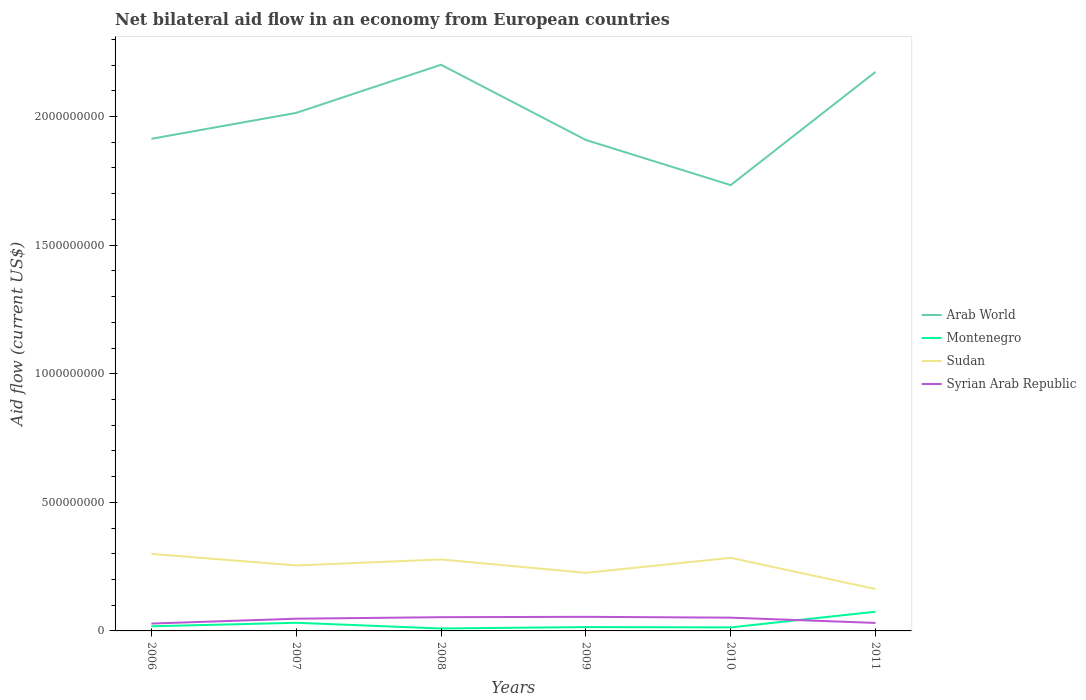Is the number of lines equal to the number of legend labels?
Provide a succinct answer. Yes. Across all years, what is the maximum net bilateral aid flow in Montenegro?
Ensure brevity in your answer.  9.50e+06. In which year was the net bilateral aid flow in Arab World maximum?
Offer a terse response. 2010. What is the total net bilateral aid flow in Sudan in the graph?
Keep it short and to the point. -6.33e+06. What is the difference between the highest and the second highest net bilateral aid flow in Arab World?
Provide a succinct answer. 4.68e+08. What is the difference between the highest and the lowest net bilateral aid flow in Arab World?
Offer a terse response. 3. How many lines are there?
Provide a short and direct response. 4. How many years are there in the graph?
Give a very brief answer. 6. What is the difference between two consecutive major ticks on the Y-axis?
Offer a very short reply. 5.00e+08. Does the graph contain grids?
Keep it short and to the point. No. How many legend labels are there?
Provide a succinct answer. 4. What is the title of the graph?
Provide a short and direct response. Net bilateral aid flow in an economy from European countries. Does "Madagascar" appear as one of the legend labels in the graph?
Provide a short and direct response. No. What is the label or title of the X-axis?
Your answer should be very brief. Years. What is the label or title of the Y-axis?
Provide a short and direct response. Aid flow (current US$). What is the Aid flow (current US$) of Arab World in 2006?
Provide a succinct answer. 1.91e+09. What is the Aid flow (current US$) in Montenegro in 2006?
Give a very brief answer. 1.81e+07. What is the Aid flow (current US$) of Sudan in 2006?
Your answer should be compact. 2.99e+08. What is the Aid flow (current US$) of Syrian Arab Republic in 2006?
Your response must be concise. 2.86e+07. What is the Aid flow (current US$) of Arab World in 2007?
Keep it short and to the point. 2.01e+09. What is the Aid flow (current US$) of Montenegro in 2007?
Your answer should be very brief. 3.16e+07. What is the Aid flow (current US$) in Sudan in 2007?
Offer a very short reply. 2.55e+08. What is the Aid flow (current US$) of Syrian Arab Republic in 2007?
Provide a short and direct response. 4.75e+07. What is the Aid flow (current US$) in Arab World in 2008?
Offer a terse response. 2.20e+09. What is the Aid flow (current US$) in Montenegro in 2008?
Keep it short and to the point. 9.50e+06. What is the Aid flow (current US$) in Sudan in 2008?
Offer a terse response. 2.78e+08. What is the Aid flow (current US$) of Syrian Arab Republic in 2008?
Offer a terse response. 5.34e+07. What is the Aid flow (current US$) in Arab World in 2009?
Offer a terse response. 1.91e+09. What is the Aid flow (current US$) of Montenegro in 2009?
Offer a terse response. 1.50e+07. What is the Aid flow (current US$) in Sudan in 2009?
Provide a short and direct response. 2.26e+08. What is the Aid flow (current US$) of Syrian Arab Republic in 2009?
Your response must be concise. 5.48e+07. What is the Aid flow (current US$) in Arab World in 2010?
Provide a short and direct response. 1.73e+09. What is the Aid flow (current US$) of Montenegro in 2010?
Ensure brevity in your answer.  1.37e+07. What is the Aid flow (current US$) of Sudan in 2010?
Ensure brevity in your answer.  2.84e+08. What is the Aid flow (current US$) of Syrian Arab Republic in 2010?
Give a very brief answer. 5.16e+07. What is the Aid flow (current US$) in Arab World in 2011?
Keep it short and to the point. 2.17e+09. What is the Aid flow (current US$) of Montenegro in 2011?
Ensure brevity in your answer.  7.47e+07. What is the Aid flow (current US$) of Sudan in 2011?
Provide a succinct answer. 1.63e+08. What is the Aid flow (current US$) in Syrian Arab Republic in 2011?
Offer a terse response. 3.11e+07. Across all years, what is the maximum Aid flow (current US$) of Arab World?
Keep it short and to the point. 2.20e+09. Across all years, what is the maximum Aid flow (current US$) in Montenegro?
Your response must be concise. 7.47e+07. Across all years, what is the maximum Aid flow (current US$) of Sudan?
Your answer should be compact. 2.99e+08. Across all years, what is the maximum Aid flow (current US$) of Syrian Arab Republic?
Your answer should be very brief. 5.48e+07. Across all years, what is the minimum Aid flow (current US$) of Arab World?
Offer a terse response. 1.73e+09. Across all years, what is the minimum Aid flow (current US$) of Montenegro?
Give a very brief answer. 9.50e+06. Across all years, what is the minimum Aid flow (current US$) in Sudan?
Offer a terse response. 1.63e+08. Across all years, what is the minimum Aid flow (current US$) in Syrian Arab Republic?
Make the answer very short. 2.86e+07. What is the total Aid flow (current US$) of Arab World in the graph?
Keep it short and to the point. 1.19e+1. What is the total Aid flow (current US$) of Montenegro in the graph?
Keep it short and to the point. 1.63e+08. What is the total Aid flow (current US$) in Sudan in the graph?
Your answer should be compact. 1.50e+09. What is the total Aid flow (current US$) in Syrian Arab Republic in the graph?
Keep it short and to the point. 2.67e+08. What is the difference between the Aid flow (current US$) of Arab World in 2006 and that in 2007?
Offer a very short reply. -1.01e+08. What is the difference between the Aid flow (current US$) in Montenegro in 2006 and that in 2007?
Your answer should be very brief. -1.34e+07. What is the difference between the Aid flow (current US$) in Sudan in 2006 and that in 2007?
Your answer should be compact. 4.47e+07. What is the difference between the Aid flow (current US$) of Syrian Arab Republic in 2006 and that in 2007?
Offer a very short reply. -1.89e+07. What is the difference between the Aid flow (current US$) of Arab World in 2006 and that in 2008?
Your answer should be compact. -2.88e+08. What is the difference between the Aid flow (current US$) in Montenegro in 2006 and that in 2008?
Your response must be concise. 8.63e+06. What is the difference between the Aid flow (current US$) of Sudan in 2006 and that in 2008?
Provide a succinct answer. 2.16e+07. What is the difference between the Aid flow (current US$) of Syrian Arab Republic in 2006 and that in 2008?
Keep it short and to the point. -2.48e+07. What is the difference between the Aid flow (current US$) in Arab World in 2006 and that in 2009?
Ensure brevity in your answer.  4.49e+06. What is the difference between the Aid flow (current US$) in Montenegro in 2006 and that in 2009?
Ensure brevity in your answer.  3.16e+06. What is the difference between the Aid flow (current US$) of Sudan in 2006 and that in 2009?
Your answer should be very brief. 7.36e+07. What is the difference between the Aid flow (current US$) in Syrian Arab Republic in 2006 and that in 2009?
Give a very brief answer. -2.62e+07. What is the difference between the Aid flow (current US$) in Arab World in 2006 and that in 2010?
Provide a short and direct response. 1.80e+08. What is the difference between the Aid flow (current US$) in Montenegro in 2006 and that in 2010?
Provide a succinct answer. 4.43e+06. What is the difference between the Aid flow (current US$) in Sudan in 2006 and that in 2010?
Offer a terse response. 1.52e+07. What is the difference between the Aid flow (current US$) in Syrian Arab Republic in 2006 and that in 2010?
Give a very brief answer. -2.30e+07. What is the difference between the Aid flow (current US$) of Arab World in 2006 and that in 2011?
Give a very brief answer. -2.60e+08. What is the difference between the Aid flow (current US$) in Montenegro in 2006 and that in 2011?
Give a very brief answer. -5.66e+07. What is the difference between the Aid flow (current US$) in Sudan in 2006 and that in 2011?
Offer a terse response. 1.37e+08. What is the difference between the Aid flow (current US$) in Syrian Arab Republic in 2006 and that in 2011?
Provide a succinct answer. -2.51e+06. What is the difference between the Aid flow (current US$) of Arab World in 2007 and that in 2008?
Give a very brief answer. -1.87e+08. What is the difference between the Aid flow (current US$) in Montenegro in 2007 and that in 2008?
Offer a very short reply. 2.21e+07. What is the difference between the Aid flow (current US$) in Sudan in 2007 and that in 2008?
Your response must be concise. -2.32e+07. What is the difference between the Aid flow (current US$) of Syrian Arab Republic in 2007 and that in 2008?
Keep it short and to the point. -5.90e+06. What is the difference between the Aid flow (current US$) of Arab World in 2007 and that in 2009?
Keep it short and to the point. 1.05e+08. What is the difference between the Aid flow (current US$) of Montenegro in 2007 and that in 2009?
Provide a short and direct response. 1.66e+07. What is the difference between the Aid flow (current US$) in Sudan in 2007 and that in 2009?
Give a very brief answer. 2.89e+07. What is the difference between the Aid flow (current US$) in Syrian Arab Republic in 2007 and that in 2009?
Your response must be concise. -7.29e+06. What is the difference between the Aid flow (current US$) in Arab World in 2007 and that in 2010?
Your response must be concise. 2.81e+08. What is the difference between the Aid flow (current US$) in Montenegro in 2007 and that in 2010?
Keep it short and to the point. 1.79e+07. What is the difference between the Aid flow (current US$) of Sudan in 2007 and that in 2010?
Provide a succinct answer. -2.95e+07. What is the difference between the Aid flow (current US$) of Syrian Arab Republic in 2007 and that in 2010?
Keep it short and to the point. -4.07e+06. What is the difference between the Aid flow (current US$) of Arab World in 2007 and that in 2011?
Keep it short and to the point. -1.59e+08. What is the difference between the Aid flow (current US$) of Montenegro in 2007 and that in 2011?
Make the answer very short. -4.32e+07. What is the difference between the Aid flow (current US$) in Sudan in 2007 and that in 2011?
Keep it short and to the point. 9.18e+07. What is the difference between the Aid flow (current US$) in Syrian Arab Republic in 2007 and that in 2011?
Provide a short and direct response. 1.64e+07. What is the difference between the Aid flow (current US$) in Arab World in 2008 and that in 2009?
Keep it short and to the point. 2.92e+08. What is the difference between the Aid flow (current US$) in Montenegro in 2008 and that in 2009?
Your answer should be compact. -5.47e+06. What is the difference between the Aid flow (current US$) in Sudan in 2008 and that in 2009?
Provide a succinct answer. 5.20e+07. What is the difference between the Aid flow (current US$) in Syrian Arab Republic in 2008 and that in 2009?
Provide a short and direct response. -1.39e+06. What is the difference between the Aid flow (current US$) of Arab World in 2008 and that in 2010?
Offer a very short reply. 4.68e+08. What is the difference between the Aid flow (current US$) of Montenegro in 2008 and that in 2010?
Ensure brevity in your answer.  -4.20e+06. What is the difference between the Aid flow (current US$) in Sudan in 2008 and that in 2010?
Offer a terse response. -6.33e+06. What is the difference between the Aid flow (current US$) of Syrian Arab Republic in 2008 and that in 2010?
Offer a very short reply. 1.83e+06. What is the difference between the Aid flow (current US$) in Arab World in 2008 and that in 2011?
Make the answer very short. 2.79e+07. What is the difference between the Aid flow (current US$) of Montenegro in 2008 and that in 2011?
Provide a succinct answer. -6.52e+07. What is the difference between the Aid flow (current US$) in Sudan in 2008 and that in 2011?
Keep it short and to the point. 1.15e+08. What is the difference between the Aid flow (current US$) of Syrian Arab Republic in 2008 and that in 2011?
Keep it short and to the point. 2.23e+07. What is the difference between the Aid flow (current US$) of Arab World in 2009 and that in 2010?
Your response must be concise. 1.75e+08. What is the difference between the Aid flow (current US$) of Montenegro in 2009 and that in 2010?
Offer a very short reply. 1.27e+06. What is the difference between the Aid flow (current US$) in Sudan in 2009 and that in 2010?
Keep it short and to the point. -5.84e+07. What is the difference between the Aid flow (current US$) in Syrian Arab Republic in 2009 and that in 2010?
Give a very brief answer. 3.22e+06. What is the difference between the Aid flow (current US$) of Arab World in 2009 and that in 2011?
Offer a terse response. -2.65e+08. What is the difference between the Aid flow (current US$) of Montenegro in 2009 and that in 2011?
Offer a very short reply. -5.98e+07. What is the difference between the Aid flow (current US$) of Sudan in 2009 and that in 2011?
Offer a terse response. 6.30e+07. What is the difference between the Aid flow (current US$) of Syrian Arab Republic in 2009 and that in 2011?
Keep it short and to the point. 2.37e+07. What is the difference between the Aid flow (current US$) in Arab World in 2010 and that in 2011?
Your answer should be very brief. -4.40e+08. What is the difference between the Aid flow (current US$) in Montenegro in 2010 and that in 2011?
Keep it short and to the point. -6.10e+07. What is the difference between the Aid flow (current US$) in Sudan in 2010 and that in 2011?
Your response must be concise. 1.21e+08. What is the difference between the Aid flow (current US$) in Syrian Arab Republic in 2010 and that in 2011?
Make the answer very short. 2.05e+07. What is the difference between the Aid flow (current US$) of Arab World in 2006 and the Aid flow (current US$) of Montenegro in 2007?
Provide a succinct answer. 1.88e+09. What is the difference between the Aid flow (current US$) of Arab World in 2006 and the Aid flow (current US$) of Sudan in 2007?
Your response must be concise. 1.66e+09. What is the difference between the Aid flow (current US$) of Arab World in 2006 and the Aid flow (current US$) of Syrian Arab Republic in 2007?
Your answer should be compact. 1.87e+09. What is the difference between the Aid flow (current US$) of Montenegro in 2006 and the Aid flow (current US$) of Sudan in 2007?
Your answer should be compact. -2.37e+08. What is the difference between the Aid flow (current US$) of Montenegro in 2006 and the Aid flow (current US$) of Syrian Arab Republic in 2007?
Provide a short and direct response. -2.94e+07. What is the difference between the Aid flow (current US$) in Sudan in 2006 and the Aid flow (current US$) in Syrian Arab Republic in 2007?
Offer a very short reply. 2.52e+08. What is the difference between the Aid flow (current US$) in Arab World in 2006 and the Aid flow (current US$) in Montenegro in 2008?
Ensure brevity in your answer.  1.90e+09. What is the difference between the Aid flow (current US$) in Arab World in 2006 and the Aid flow (current US$) in Sudan in 2008?
Your response must be concise. 1.64e+09. What is the difference between the Aid flow (current US$) of Arab World in 2006 and the Aid flow (current US$) of Syrian Arab Republic in 2008?
Offer a very short reply. 1.86e+09. What is the difference between the Aid flow (current US$) in Montenegro in 2006 and the Aid flow (current US$) in Sudan in 2008?
Your response must be concise. -2.60e+08. What is the difference between the Aid flow (current US$) of Montenegro in 2006 and the Aid flow (current US$) of Syrian Arab Republic in 2008?
Make the answer very short. -3.53e+07. What is the difference between the Aid flow (current US$) of Sudan in 2006 and the Aid flow (current US$) of Syrian Arab Republic in 2008?
Provide a short and direct response. 2.46e+08. What is the difference between the Aid flow (current US$) of Arab World in 2006 and the Aid flow (current US$) of Montenegro in 2009?
Provide a short and direct response. 1.90e+09. What is the difference between the Aid flow (current US$) in Arab World in 2006 and the Aid flow (current US$) in Sudan in 2009?
Your response must be concise. 1.69e+09. What is the difference between the Aid flow (current US$) of Arab World in 2006 and the Aid flow (current US$) of Syrian Arab Republic in 2009?
Provide a succinct answer. 1.86e+09. What is the difference between the Aid flow (current US$) of Montenegro in 2006 and the Aid flow (current US$) of Sudan in 2009?
Provide a succinct answer. -2.08e+08. What is the difference between the Aid flow (current US$) of Montenegro in 2006 and the Aid flow (current US$) of Syrian Arab Republic in 2009?
Offer a terse response. -3.67e+07. What is the difference between the Aid flow (current US$) in Sudan in 2006 and the Aid flow (current US$) in Syrian Arab Republic in 2009?
Give a very brief answer. 2.45e+08. What is the difference between the Aid flow (current US$) of Arab World in 2006 and the Aid flow (current US$) of Montenegro in 2010?
Provide a succinct answer. 1.90e+09. What is the difference between the Aid flow (current US$) of Arab World in 2006 and the Aid flow (current US$) of Sudan in 2010?
Provide a short and direct response. 1.63e+09. What is the difference between the Aid flow (current US$) of Arab World in 2006 and the Aid flow (current US$) of Syrian Arab Republic in 2010?
Ensure brevity in your answer.  1.86e+09. What is the difference between the Aid flow (current US$) of Montenegro in 2006 and the Aid flow (current US$) of Sudan in 2010?
Give a very brief answer. -2.66e+08. What is the difference between the Aid flow (current US$) of Montenegro in 2006 and the Aid flow (current US$) of Syrian Arab Republic in 2010?
Give a very brief answer. -3.35e+07. What is the difference between the Aid flow (current US$) in Sudan in 2006 and the Aid flow (current US$) in Syrian Arab Republic in 2010?
Give a very brief answer. 2.48e+08. What is the difference between the Aid flow (current US$) of Arab World in 2006 and the Aid flow (current US$) of Montenegro in 2011?
Give a very brief answer. 1.84e+09. What is the difference between the Aid flow (current US$) of Arab World in 2006 and the Aid flow (current US$) of Sudan in 2011?
Make the answer very short. 1.75e+09. What is the difference between the Aid flow (current US$) in Arab World in 2006 and the Aid flow (current US$) in Syrian Arab Republic in 2011?
Ensure brevity in your answer.  1.88e+09. What is the difference between the Aid flow (current US$) in Montenegro in 2006 and the Aid flow (current US$) in Sudan in 2011?
Ensure brevity in your answer.  -1.45e+08. What is the difference between the Aid flow (current US$) in Montenegro in 2006 and the Aid flow (current US$) in Syrian Arab Republic in 2011?
Ensure brevity in your answer.  -1.30e+07. What is the difference between the Aid flow (current US$) of Sudan in 2006 and the Aid flow (current US$) of Syrian Arab Republic in 2011?
Provide a succinct answer. 2.68e+08. What is the difference between the Aid flow (current US$) in Arab World in 2007 and the Aid flow (current US$) in Montenegro in 2008?
Provide a short and direct response. 2.00e+09. What is the difference between the Aid flow (current US$) of Arab World in 2007 and the Aid flow (current US$) of Sudan in 2008?
Offer a very short reply. 1.74e+09. What is the difference between the Aid flow (current US$) of Arab World in 2007 and the Aid flow (current US$) of Syrian Arab Republic in 2008?
Your answer should be compact. 1.96e+09. What is the difference between the Aid flow (current US$) of Montenegro in 2007 and the Aid flow (current US$) of Sudan in 2008?
Offer a very short reply. -2.46e+08. What is the difference between the Aid flow (current US$) in Montenegro in 2007 and the Aid flow (current US$) in Syrian Arab Republic in 2008?
Keep it short and to the point. -2.18e+07. What is the difference between the Aid flow (current US$) in Sudan in 2007 and the Aid flow (current US$) in Syrian Arab Republic in 2008?
Your answer should be compact. 2.01e+08. What is the difference between the Aid flow (current US$) in Arab World in 2007 and the Aid flow (current US$) in Montenegro in 2009?
Ensure brevity in your answer.  2.00e+09. What is the difference between the Aid flow (current US$) of Arab World in 2007 and the Aid flow (current US$) of Sudan in 2009?
Your answer should be compact. 1.79e+09. What is the difference between the Aid flow (current US$) of Arab World in 2007 and the Aid flow (current US$) of Syrian Arab Republic in 2009?
Offer a very short reply. 1.96e+09. What is the difference between the Aid flow (current US$) of Montenegro in 2007 and the Aid flow (current US$) of Sudan in 2009?
Your answer should be very brief. -1.94e+08. What is the difference between the Aid flow (current US$) of Montenegro in 2007 and the Aid flow (current US$) of Syrian Arab Republic in 2009?
Provide a succinct answer. -2.32e+07. What is the difference between the Aid flow (current US$) in Sudan in 2007 and the Aid flow (current US$) in Syrian Arab Republic in 2009?
Your response must be concise. 2.00e+08. What is the difference between the Aid flow (current US$) of Arab World in 2007 and the Aid flow (current US$) of Montenegro in 2010?
Your answer should be very brief. 2.00e+09. What is the difference between the Aid flow (current US$) in Arab World in 2007 and the Aid flow (current US$) in Sudan in 2010?
Your answer should be very brief. 1.73e+09. What is the difference between the Aid flow (current US$) of Arab World in 2007 and the Aid flow (current US$) of Syrian Arab Republic in 2010?
Give a very brief answer. 1.96e+09. What is the difference between the Aid flow (current US$) in Montenegro in 2007 and the Aid flow (current US$) in Sudan in 2010?
Offer a terse response. -2.53e+08. What is the difference between the Aid flow (current US$) of Montenegro in 2007 and the Aid flow (current US$) of Syrian Arab Republic in 2010?
Offer a terse response. -2.00e+07. What is the difference between the Aid flow (current US$) of Sudan in 2007 and the Aid flow (current US$) of Syrian Arab Republic in 2010?
Give a very brief answer. 2.03e+08. What is the difference between the Aid flow (current US$) in Arab World in 2007 and the Aid flow (current US$) in Montenegro in 2011?
Your response must be concise. 1.94e+09. What is the difference between the Aid flow (current US$) of Arab World in 2007 and the Aid flow (current US$) of Sudan in 2011?
Your answer should be compact. 1.85e+09. What is the difference between the Aid flow (current US$) in Arab World in 2007 and the Aid flow (current US$) in Syrian Arab Republic in 2011?
Give a very brief answer. 1.98e+09. What is the difference between the Aid flow (current US$) in Montenegro in 2007 and the Aid flow (current US$) in Sudan in 2011?
Offer a very short reply. -1.31e+08. What is the difference between the Aid flow (current US$) in Montenegro in 2007 and the Aid flow (current US$) in Syrian Arab Republic in 2011?
Your answer should be very brief. 4.80e+05. What is the difference between the Aid flow (current US$) of Sudan in 2007 and the Aid flow (current US$) of Syrian Arab Republic in 2011?
Make the answer very short. 2.24e+08. What is the difference between the Aid flow (current US$) of Arab World in 2008 and the Aid flow (current US$) of Montenegro in 2009?
Ensure brevity in your answer.  2.19e+09. What is the difference between the Aid flow (current US$) of Arab World in 2008 and the Aid flow (current US$) of Sudan in 2009?
Provide a succinct answer. 1.98e+09. What is the difference between the Aid flow (current US$) in Arab World in 2008 and the Aid flow (current US$) in Syrian Arab Republic in 2009?
Your answer should be very brief. 2.15e+09. What is the difference between the Aid flow (current US$) in Montenegro in 2008 and the Aid flow (current US$) in Sudan in 2009?
Ensure brevity in your answer.  -2.16e+08. What is the difference between the Aid flow (current US$) of Montenegro in 2008 and the Aid flow (current US$) of Syrian Arab Republic in 2009?
Keep it short and to the point. -4.53e+07. What is the difference between the Aid flow (current US$) of Sudan in 2008 and the Aid flow (current US$) of Syrian Arab Republic in 2009?
Offer a terse response. 2.23e+08. What is the difference between the Aid flow (current US$) in Arab World in 2008 and the Aid flow (current US$) in Montenegro in 2010?
Make the answer very short. 2.19e+09. What is the difference between the Aid flow (current US$) of Arab World in 2008 and the Aid flow (current US$) of Sudan in 2010?
Give a very brief answer. 1.92e+09. What is the difference between the Aid flow (current US$) in Arab World in 2008 and the Aid flow (current US$) in Syrian Arab Republic in 2010?
Offer a very short reply. 2.15e+09. What is the difference between the Aid flow (current US$) of Montenegro in 2008 and the Aid flow (current US$) of Sudan in 2010?
Make the answer very short. -2.75e+08. What is the difference between the Aid flow (current US$) of Montenegro in 2008 and the Aid flow (current US$) of Syrian Arab Republic in 2010?
Your answer should be compact. -4.21e+07. What is the difference between the Aid flow (current US$) of Sudan in 2008 and the Aid flow (current US$) of Syrian Arab Republic in 2010?
Offer a very short reply. 2.26e+08. What is the difference between the Aid flow (current US$) of Arab World in 2008 and the Aid flow (current US$) of Montenegro in 2011?
Your answer should be very brief. 2.13e+09. What is the difference between the Aid flow (current US$) of Arab World in 2008 and the Aid flow (current US$) of Sudan in 2011?
Keep it short and to the point. 2.04e+09. What is the difference between the Aid flow (current US$) in Arab World in 2008 and the Aid flow (current US$) in Syrian Arab Republic in 2011?
Your answer should be compact. 2.17e+09. What is the difference between the Aid flow (current US$) in Montenegro in 2008 and the Aid flow (current US$) in Sudan in 2011?
Offer a very short reply. -1.53e+08. What is the difference between the Aid flow (current US$) of Montenegro in 2008 and the Aid flow (current US$) of Syrian Arab Republic in 2011?
Your answer should be compact. -2.16e+07. What is the difference between the Aid flow (current US$) of Sudan in 2008 and the Aid flow (current US$) of Syrian Arab Republic in 2011?
Your answer should be compact. 2.47e+08. What is the difference between the Aid flow (current US$) in Arab World in 2009 and the Aid flow (current US$) in Montenegro in 2010?
Give a very brief answer. 1.90e+09. What is the difference between the Aid flow (current US$) of Arab World in 2009 and the Aid flow (current US$) of Sudan in 2010?
Your answer should be very brief. 1.62e+09. What is the difference between the Aid flow (current US$) in Arab World in 2009 and the Aid flow (current US$) in Syrian Arab Republic in 2010?
Ensure brevity in your answer.  1.86e+09. What is the difference between the Aid flow (current US$) in Montenegro in 2009 and the Aid flow (current US$) in Sudan in 2010?
Your answer should be very brief. -2.69e+08. What is the difference between the Aid flow (current US$) in Montenegro in 2009 and the Aid flow (current US$) in Syrian Arab Republic in 2010?
Make the answer very short. -3.66e+07. What is the difference between the Aid flow (current US$) of Sudan in 2009 and the Aid flow (current US$) of Syrian Arab Republic in 2010?
Offer a terse response. 1.74e+08. What is the difference between the Aid flow (current US$) of Arab World in 2009 and the Aid flow (current US$) of Montenegro in 2011?
Your answer should be compact. 1.83e+09. What is the difference between the Aid flow (current US$) in Arab World in 2009 and the Aid flow (current US$) in Sudan in 2011?
Your response must be concise. 1.75e+09. What is the difference between the Aid flow (current US$) of Arab World in 2009 and the Aid flow (current US$) of Syrian Arab Republic in 2011?
Keep it short and to the point. 1.88e+09. What is the difference between the Aid flow (current US$) in Montenegro in 2009 and the Aid flow (current US$) in Sudan in 2011?
Give a very brief answer. -1.48e+08. What is the difference between the Aid flow (current US$) of Montenegro in 2009 and the Aid flow (current US$) of Syrian Arab Republic in 2011?
Your answer should be very brief. -1.61e+07. What is the difference between the Aid flow (current US$) in Sudan in 2009 and the Aid flow (current US$) in Syrian Arab Republic in 2011?
Provide a short and direct response. 1.95e+08. What is the difference between the Aid flow (current US$) in Arab World in 2010 and the Aid flow (current US$) in Montenegro in 2011?
Provide a succinct answer. 1.66e+09. What is the difference between the Aid flow (current US$) of Arab World in 2010 and the Aid flow (current US$) of Sudan in 2011?
Your answer should be compact. 1.57e+09. What is the difference between the Aid flow (current US$) in Arab World in 2010 and the Aid flow (current US$) in Syrian Arab Republic in 2011?
Provide a short and direct response. 1.70e+09. What is the difference between the Aid flow (current US$) of Montenegro in 2010 and the Aid flow (current US$) of Sudan in 2011?
Your answer should be compact. -1.49e+08. What is the difference between the Aid flow (current US$) of Montenegro in 2010 and the Aid flow (current US$) of Syrian Arab Republic in 2011?
Give a very brief answer. -1.74e+07. What is the difference between the Aid flow (current US$) of Sudan in 2010 and the Aid flow (current US$) of Syrian Arab Republic in 2011?
Your answer should be very brief. 2.53e+08. What is the average Aid flow (current US$) in Arab World per year?
Provide a succinct answer. 1.99e+09. What is the average Aid flow (current US$) in Montenegro per year?
Provide a short and direct response. 2.71e+07. What is the average Aid flow (current US$) in Sudan per year?
Your answer should be very brief. 2.51e+08. What is the average Aid flow (current US$) in Syrian Arab Republic per year?
Provide a short and direct response. 4.45e+07. In the year 2006, what is the difference between the Aid flow (current US$) in Arab World and Aid flow (current US$) in Montenegro?
Provide a short and direct response. 1.90e+09. In the year 2006, what is the difference between the Aid flow (current US$) in Arab World and Aid flow (current US$) in Sudan?
Ensure brevity in your answer.  1.61e+09. In the year 2006, what is the difference between the Aid flow (current US$) of Arab World and Aid flow (current US$) of Syrian Arab Republic?
Your response must be concise. 1.88e+09. In the year 2006, what is the difference between the Aid flow (current US$) in Montenegro and Aid flow (current US$) in Sudan?
Your answer should be compact. -2.81e+08. In the year 2006, what is the difference between the Aid flow (current US$) in Montenegro and Aid flow (current US$) in Syrian Arab Republic?
Your answer should be compact. -1.04e+07. In the year 2006, what is the difference between the Aid flow (current US$) in Sudan and Aid flow (current US$) in Syrian Arab Republic?
Ensure brevity in your answer.  2.71e+08. In the year 2007, what is the difference between the Aid flow (current US$) of Arab World and Aid flow (current US$) of Montenegro?
Your response must be concise. 1.98e+09. In the year 2007, what is the difference between the Aid flow (current US$) of Arab World and Aid flow (current US$) of Sudan?
Offer a very short reply. 1.76e+09. In the year 2007, what is the difference between the Aid flow (current US$) in Arab World and Aid flow (current US$) in Syrian Arab Republic?
Ensure brevity in your answer.  1.97e+09. In the year 2007, what is the difference between the Aid flow (current US$) in Montenegro and Aid flow (current US$) in Sudan?
Keep it short and to the point. -2.23e+08. In the year 2007, what is the difference between the Aid flow (current US$) of Montenegro and Aid flow (current US$) of Syrian Arab Republic?
Your answer should be very brief. -1.60e+07. In the year 2007, what is the difference between the Aid flow (current US$) of Sudan and Aid flow (current US$) of Syrian Arab Republic?
Your response must be concise. 2.07e+08. In the year 2008, what is the difference between the Aid flow (current US$) in Arab World and Aid flow (current US$) in Montenegro?
Provide a succinct answer. 2.19e+09. In the year 2008, what is the difference between the Aid flow (current US$) of Arab World and Aid flow (current US$) of Sudan?
Your answer should be very brief. 1.92e+09. In the year 2008, what is the difference between the Aid flow (current US$) in Arab World and Aid flow (current US$) in Syrian Arab Republic?
Offer a very short reply. 2.15e+09. In the year 2008, what is the difference between the Aid flow (current US$) in Montenegro and Aid flow (current US$) in Sudan?
Your answer should be very brief. -2.68e+08. In the year 2008, what is the difference between the Aid flow (current US$) in Montenegro and Aid flow (current US$) in Syrian Arab Republic?
Your answer should be compact. -4.39e+07. In the year 2008, what is the difference between the Aid flow (current US$) of Sudan and Aid flow (current US$) of Syrian Arab Republic?
Your answer should be compact. 2.24e+08. In the year 2009, what is the difference between the Aid flow (current US$) of Arab World and Aid flow (current US$) of Montenegro?
Your response must be concise. 1.89e+09. In the year 2009, what is the difference between the Aid flow (current US$) of Arab World and Aid flow (current US$) of Sudan?
Your answer should be very brief. 1.68e+09. In the year 2009, what is the difference between the Aid flow (current US$) in Arab World and Aid flow (current US$) in Syrian Arab Republic?
Keep it short and to the point. 1.85e+09. In the year 2009, what is the difference between the Aid flow (current US$) in Montenegro and Aid flow (current US$) in Sudan?
Make the answer very short. -2.11e+08. In the year 2009, what is the difference between the Aid flow (current US$) of Montenegro and Aid flow (current US$) of Syrian Arab Republic?
Give a very brief answer. -3.98e+07. In the year 2009, what is the difference between the Aid flow (current US$) of Sudan and Aid flow (current US$) of Syrian Arab Republic?
Provide a succinct answer. 1.71e+08. In the year 2010, what is the difference between the Aid flow (current US$) in Arab World and Aid flow (current US$) in Montenegro?
Give a very brief answer. 1.72e+09. In the year 2010, what is the difference between the Aid flow (current US$) of Arab World and Aid flow (current US$) of Sudan?
Make the answer very short. 1.45e+09. In the year 2010, what is the difference between the Aid flow (current US$) of Arab World and Aid flow (current US$) of Syrian Arab Republic?
Ensure brevity in your answer.  1.68e+09. In the year 2010, what is the difference between the Aid flow (current US$) of Montenegro and Aid flow (current US$) of Sudan?
Ensure brevity in your answer.  -2.70e+08. In the year 2010, what is the difference between the Aid flow (current US$) of Montenegro and Aid flow (current US$) of Syrian Arab Republic?
Your answer should be very brief. -3.79e+07. In the year 2010, what is the difference between the Aid flow (current US$) of Sudan and Aid flow (current US$) of Syrian Arab Republic?
Provide a succinct answer. 2.33e+08. In the year 2011, what is the difference between the Aid flow (current US$) of Arab World and Aid flow (current US$) of Montenegro?
Offer a very short reply. 2.10e+09. In the year 2011, what is the difference between the Aid flow (current US$) in Arab World and Aid flow (current US$) in Sudan?
Provide a short and direct response. 2.01e+09. In the year 2011, what is the difference between the Aid flow (current US$) of Arab World and Aid flow (current US$) of Syrian Arab Republic?
Your response must be concise. 2.14e+09. In the year 2011, what is the difference between the Aid flow (current US$) in Montenegro and Aid flow (current US$) in Sudan?
Provide a short and direct response. -8.81e+07. In the year 2011, what is the difference between the Aid flow (current US$) in Montenegro and Aid flow (current US$) in Syrian Arab Republic?
Your answer should be very brief. 4.36e+07. In the year 2011, what is the difference between the Aid flow (current US$) of Sudan and Aid flow (current US$) of Syrian Arab Republic?
Provide a short and direct response. 1.32e+08. What is the ratio of the Aid flow (current US$) in Arab World in 2006 to that in 2007?
Keep it short and to the point. 0.95. What is the ratio of the Aid flow (current US$) of Montenegro in 2006 to that in 2007?
Offer a terse response. 0.57. What is the ratio of the Aid flow (current US$) in Sudan in 2006 to that in 2007?
Make the answer very short. 1.18. What is the ratio of the Aid flow (current US$) of Syrian Arab Republic in 2006 to that in 2007?
Your response must be concise. 0.6. What is the ratio of the Aid flow (current US$) of Arab World in 2006 to that in 2008?
Ensure brevity in your answer.  0.87. What is the ratio of the Aid flow (current US$) of Montenegro in 2006 to that in 2008?
Give a very brief answer. 1.91. What is the ratio of the Aid flow (current US$) of Sudan in 2006 to that in 2008?
Keep it short and to the point. 1.08. What is the ratio of the Aid flow (current US$) of Syrian Arab Republic in 2006 to that in 2008?
Provide a short and direct response. 0.54. What is the ratio of the Aid flow (current US$) of Arab World in 2006 to that in 2009?
Provide a short and direct response. 1. What is the ratio of the Aid flow (current US$) of Montenegro in 2006 to that in 2009?
Offer a very short reply. 1.21. What is the ratio of the Aid flow (current US$) of Sudan in 2006 to that in 2009?
Provide a succinct answer. 1.33. What is the ratio of the Aid flow (current US$) in Syrian Arab Republic in 2006 to that in 2009?
Provide a succinct answer. 0.52. What is the ratio of the Aid flow (current US$) in Arab World in 2006 to that in 2010?
Keep it short and to the point. 1.1. What is the ratio of the Aid flow (current US$) in Montenegro in 2006 to that in 2010?
Your answer should be compact. 1.32. What is the ratio of the Aid flow (current US$) of Sudan in 2006 to that in 2010?
Keep it short and to the point. 1.05. What is the ratio of the Aid flow (current US$) in Syrian Arab Republic in 2006 to that in 2010?
Offer a very short reply. 0.55. What is the ratio of the Aid flow (current US$) in Arab World in 2006 to that in 2011?
Give a very brief answer. 0.88. What is the ratio of the Aid flow (current US$) of Montenegro in 2006 to that in 2011?
Ensure brevity in your answer.  0.24. What is the ratio of the Aid flow (current US$) of Sudan in 2006 to that in 2011?
Provide a succinct answer. 1.84. What is the ratio of the Aid flow (current US$) in Syrian Arab Republic in 2006 to that in 2011?
Your answer should be very brief. 0.92. What is the ratio of the Aid flow (current US$) of Arab World in 2007 to that in 2008?
Your response must be concise. 0.92. What is the ratio of the Aid flow (current US$) of Montenegro in 2007 to that in 2008?
Your response must be concise. 3.32. What is the ratio of the Aid flow (current US$) of Sudan in 2007 to that in 2008?
Offer a very short reply. 0.92. What is the ratio of the Aid flow (current US$) of Syrian Arab Republic in 2007 to that in 2008?
Your answer should be compact. 0.89. What is the ratio of the Aid flow (current US$) in Arab World in 2007 to that in 2009?
Ensure brevity in your answer.  1.06. What is the ratio of the Aid flow (current US$) of Montenegro in 2007 to that in 2009?
Give a very brief answer. 2.11. What is the ratio of the Aid flow (current US$) in Sudan in 2007 to that in 2009?
Your response must be concise. 1.13. What is the ratio of the Aid flow (current US$) in Syrian Arab Republic in 2007 to that in 2009?
Provide a succinct answer. 0.87. What is the ratio of the Aid flow (current US$) of Arab World in 2007 to that in 2010?
Offer a very short reply. 1.16. What is the ratio of the Aid flow (current US$) in Montenegro in 2007 to that in 2010?
Provide a succinct answer. 2.3. What is the ratio of the Aid flow (current US$) in Sudan in 2007 to that in 2010?
Your answer should be very brief. 0.9. What is the ratio of the Aid flow (current US$) in Syrian Arab Republic in 2007 to that in 2010?
Provide a short and direct response. 0.92. What is the ratio of the Aid flow (current US$) of Arab World in 2007 to that in 2011?
Your answer should be very brief. 0.93. What is the ratio of the Aid flow (current US$) in Montenegro in 2007 to that in 2011?
Offer a very short reply. 0.42. What is the ratio of the Aid flow (current US$) of Sudan in 2007 to that in 2011?
Your response must be concise. 1.56. What is the ratio of the Aid flow (current US$) in Syrian Arab Republic in 2007 to that in 2011?
Provide a short and direct response. 1.53. What is the ratio of the Aid flow (current US$) of Arab World in 2008 to that in 2009?
Offer a very short reply. 1.15. What is the ratio of the Aid flow (current US$) of Montenegro in 2008 to that in 2009?
Give a very brief answer. 0.63. What is the ratio of the Aid flow (current US$) in Sudan in 2008 to that in 2009?
Provide a succinct answer. 1.23. What is the ratio of the Aid flow (current US$) of Syrian Arab Republic in 2008 to that in 2009?
Give a very brief answer. 0.97. What is the ratio of the Aid flow (current US$) in Arab World in 2008 to that in 2010?
Provide a short and direct response. 1.27. What is the ratio of the Aid flow (current US$) of Montenegro in 2008 to that in 2010?
Provide a short and direct response. 0.69. What is the ratio of the Aid flow (current US$) in Sudan in 2008 to that in 2010?
Make the answer very short. 0.98. What is the ratio of the Aid flow (current US$) in Syrian Arab Republic in 2008 to that in 2010?
Offer a terse response. 1.04. What is the ratio of the Aid flow (current US$) in Arab World in 2008 to that in 2011?
Offer a terse response. 1.01. What is the ratio of the Aid flow (current US$) of Montenegro in 2008 to that in 2011?
Your response must be concise. 0.13. What is the ratio of the Aid flow (current US$) in Sudan in 2008 to that in 2011?
Ensure brevity in your answer.  1.71. What is the ratio of the Aid flow (current US$) in Syrian Arab Republic in 2008 to that in 2011?
Make the answer very short. 1.72. What is the ratio of the Aid flow (current US$) in Arab World in 2009 to that in 2010?
Make the answer very short. 1.1. What is the ratio of the Aid flow (current US$) of Montenegro in 2009 to that in 2010?
Make the answer very short. 1.09. What is the ratio of the Aid flow (current US$) of Sudan in 2009 to that in 2010?
Your answer should be very brief. 0.79. What is the ratio of the Aid flow (current US$) of Syrian Arab Republic in 2009 to that in 2010?
Offer a terse response. 1.06. What is the ratio of the Aid flow (current US$) of Arab World in 2009 to that in 2011?
Make the answer very short. 0.88. What is the ratio of the Aid flow (current US$) of Montenegro in 2009 to that in 2011?
Offer a very short reply. 0.2. What is the ratio of the Aid flow (current US$) of Sudan in 2009 to that in 2011?
Make the answer very short. 1.39. What is the ratio of the Aid flow (current US$) in Syrian Arab Republic in 2009 to that in 2011?
Make the answer very short. 1.76. What is the ratio of the Aid flow (current US$) of Arab World in 2010 to that in 2011?
Give a very brief answer. 0.8. What is the ratio of the Aid flow (current US$) of Montenegro in 2010 to that in 2011?
Make the answer very short. 0.18. What is the ratio of the Aid flow (current US$) of Sudan in 2010 to that in 2011?
Give a very brief answer. 1.74. What is the ratio of the Aid flow (current US$) in Syrian Arab Republic in 2010 to that in 2011?
Keep it short and to the point. 1.66. What is the difference between the highest and the second highest Aid flow (current US$) in Arab World?
Offer a terse response. 2.79e+07. What is the difference between the highest and the second highest Aid flow (current US$) of Montenegro?
Your response must be concise. 4.32e+07. What is the difference between the highest and the second highest Aid flow (current US$) in Sudan?
Provide a short and direct response. 1.52e+07. What is the difference between the highest and the second highest Aid flow (current US$) of Syrian Arab Republic?
Your answer should be compact. 1.39e+06. What is the difference between the highest and the lowest Aid flow (current US$) of Arab World?
Keep it short and to the point. 4.68e+08. What is the difference between the highest and the lowest Aid flow (current US$) of Montenegro?
Provide a succinct answer. 6.52e+07. What is the difference between the highest and the lowest Aid flow (current US$) of Sudan?
Keep it short and to the point. 1.37e+08. What is the difference between the highest and the lowest Aid flow (current US$) in Syrian Arab Republic?
Your answer should be compact. 2.62e+07. 